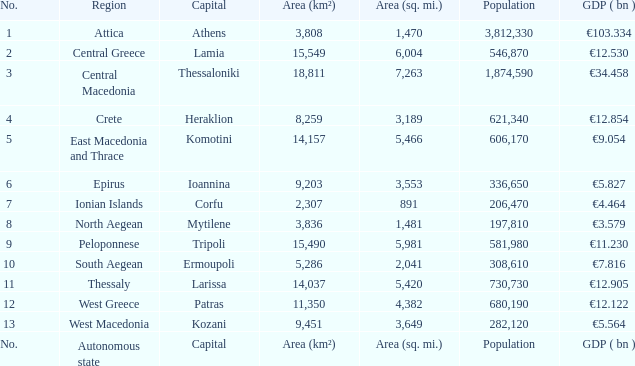What is the gdp (bn) where the chief city is the capital? GDP ( bn ). 